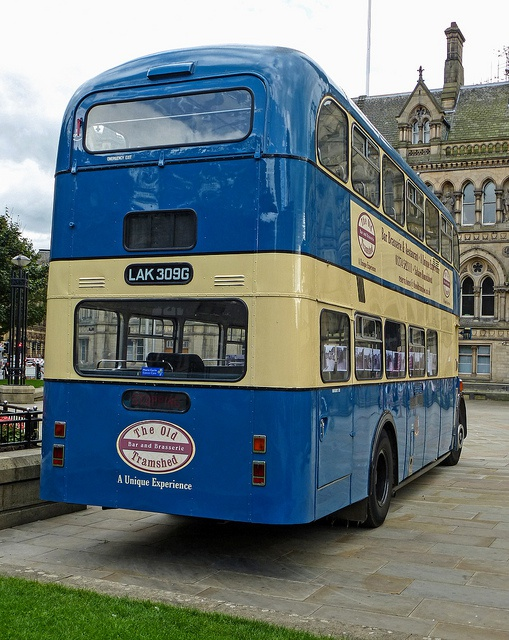Describe the objects in this image and their specific colors. I can see bus in white, darkblue, black, tan, and blue tones, traffic light in white, black, gray, darkgray, and purple tones, and traffic light in white, black, and gray tones in this image. 